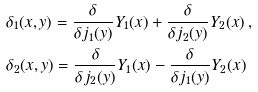<formula> <loc_0><loc_0><loc_500><loc_500>& \delta _ { 1 } ( x , y ) = \frac { \delta } { \delta j _ { 1 } ( y ) } Y _ { 1 } ( x ) + \frac { \delta } { \delta j _ { 2 } ( y ) } Y _ { 2 } ( x ) \, , \\ & \delta _ { 2 } ( x , y ) = \frac { \delta } { \delta j _ { 2 } ( y ) } Y _ { 1 } ( x ) - \frac { \delta } { \delta j _ { 1 } ( y ) } Y _ { 2 } ( x )</formula> 